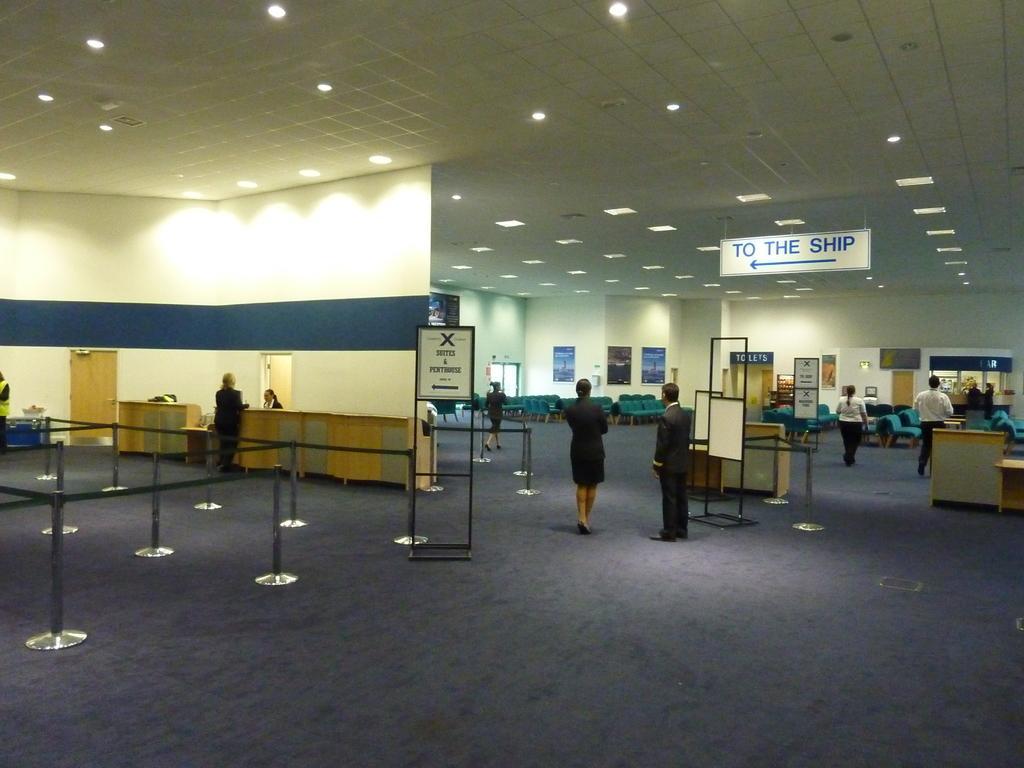Can you describe this image briefly? In this image we can see the people standing on the ground. And there are tables, boards, rods and chairs on the ground. We can see the wall with posters and door. At the top we can see the ceiling with lights and board with text. 